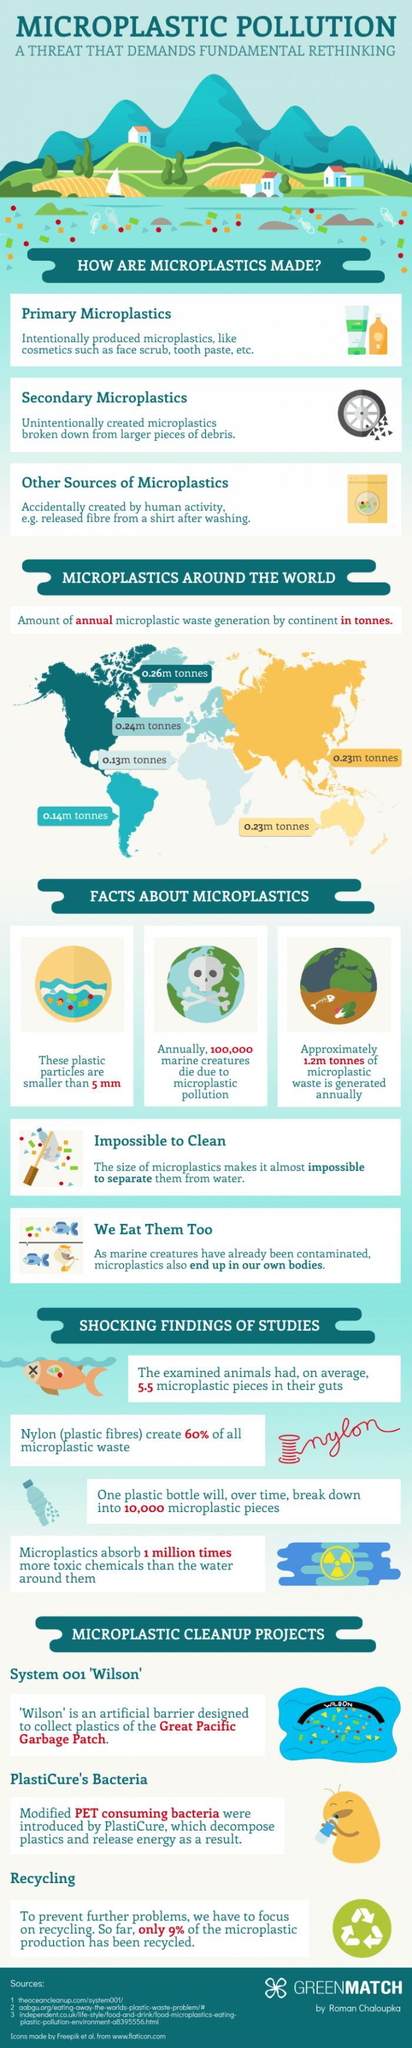On the basis of how plastics are made, which are the three types into which microplastics can be categorised?
Answer the question with a short phrase. Primary microplastics, secondary microplastics, other sources of microplastics Which type of microplastics are not intentionally created, but broken down from larger debris? Secondary microplastics How much microplastic waste is generated each year (approx)? 1.2m tonnes What is the size of micro plastic particles (approx)? 5 mm How many continents produce more than 0.20m tonnes of microplastics each year? 4 How many "shocking findings"  on microplastics are mentioned here? 4 How many microplastic cleanup projects are mentioned here? 3 Which company developed the PET consuming bacteria? PlastiCure Which are the three microplastics cleanup projects? System 001 'Wilson', Plasticure's bacteria, recycling Which project acts as a barrier of the Great Pacific Garbage patch? Wilson What makes it impossible for us to separate microplastic from water - Marine creatures, size of particles or plastic bottle? Size of particles Which type of micro plastics are intentionally created? Primary microplastics How many Marine creatures die due to microplastic pollution each year? 100,000 What percent of the micro plastic production has 'not been recycled'? 91 Which absorbs more toxic chemicals - water or microplastics? Microplastics How many continents produce less than 0.20m tonnes of microplastics each year? 2 Which fibre is a source of micro plastic waste? Nylon 